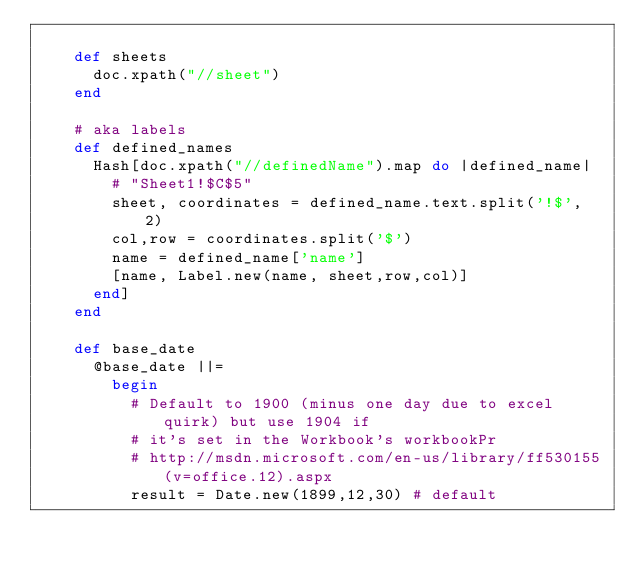Convert code to text. <code><loc_0><loc_0><loc_500><loc_500><_Ruby_>
    def sheets
      doc.xpath("//sheet")
    end

    # aka labels
    def defined_names
      Hash[doc.xpath("//definedName").map do |defined_name|
        # "Sheet1!$C$5"
        sheet, coordinates = defined_name.text.split('!$', 2)
        col,row = coordinates.split('$')
        name = defined_name['name']
        [name, Label.new(name, sheet,row,col)]
      end]
    end

    def base_date
      @base_date ||=
        begin
          # Default to 1900 (minus one day due to excel quirk) but use 1904 if
          # it's set in the Workbook's workbookPr
          # http://msdn.microsoft.com/en-us/library/ff530155(v=office.12).aspx
          result = Date.new(1899,12,30) # default</code> 